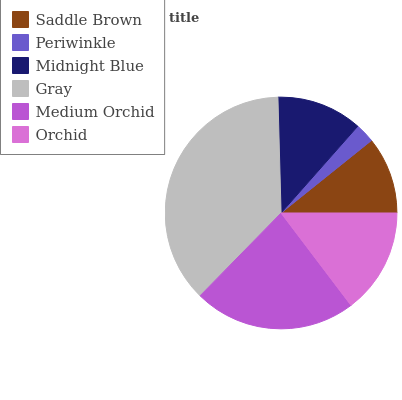Is Periwinkle the minimum?
Answer yes or no. Yes. Is Gray the maximum?
Answer yes or no. Yes. Is Midnight Blue the minimum?
Answer yes or no. No. Is Midnight Blue the maximum?
Answer yes or no. No. Is Midnight Blue greater than Periwinkle?
Answer yes or no. Yes. Is Periwinkle less than Midnight Blue?
Answer yes or no. Yes. Is Periwinkle greater than Midnight Blue?
Answer yes or no. No. Is Midnight Blue less than Periwinkle?
Answer yes or no. No. Is Orchid the high median?
Answer yes or no. Yes. Is Midnight Blue the low median?
Answer yes or no. Yes. Is Midnight Blue the high median?
Answer yes or no. No. Is Periwinkle the low median?
Answer yes or no. No. 